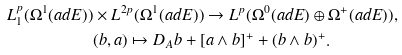<formula> <loc_0><loc_0><loc_500><loc_500>L ^ { p } _ { 1 } ( \Omega ^ { 1 } ( a d E ) ) & \times L ^ { 2 p } ( \Omega ^ { 1 } ( a d E ) ) \rightarrow L ^ { p } ( \Omega ^ { 0 } ( a d E ) \oplus \Omega ^ { + } ( a d E ) ) , \\ & ( b , a ) \mapsto D _ { A } b + [ a \wedge b ] ^ { + } + ( b \wedge b ) ^ { + } .</formula> 